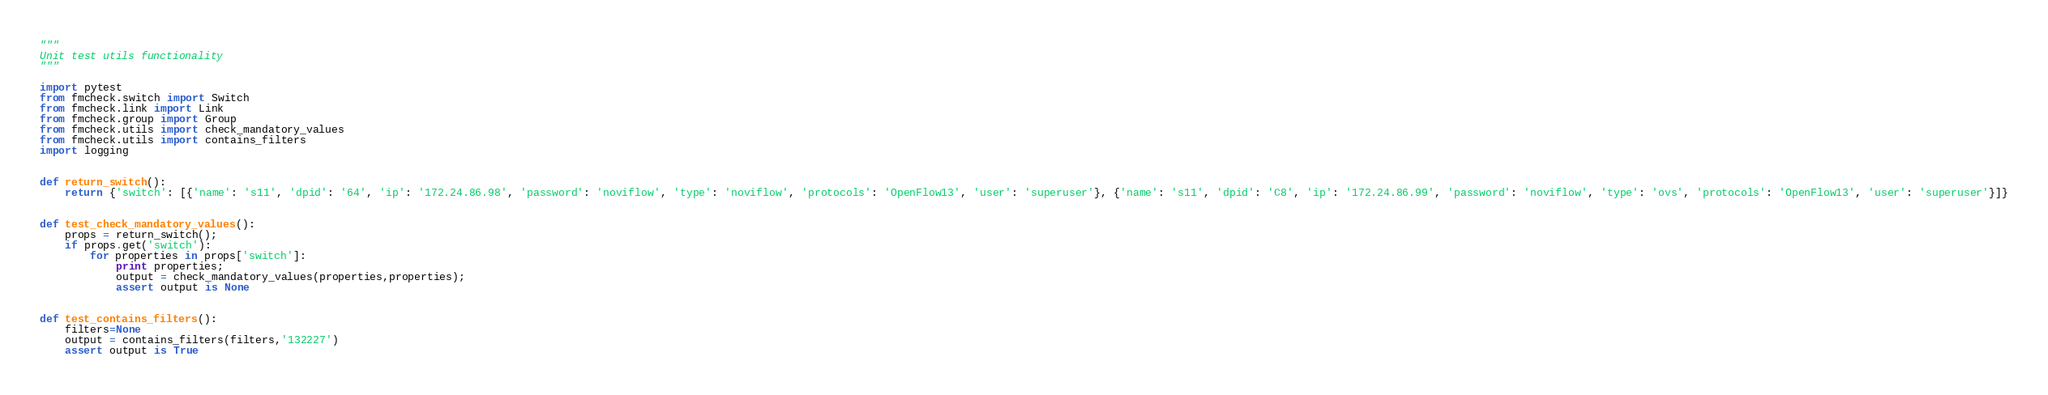<code> <loc_0><loc_0><loc_500><loc_500><_Python_>"""
Unit test utils functionality 
"""

import pytest
from fmcheck.switch import Switch
from fmcheck.link import Link
from fmcheck.group import Group
from fmcheck.utils import check_mandatory_values
from fmcheck.utils import contains_filters
import logging


def return_switch():
    return {'switch': [{'name': 's11', 'dpid': '64', 'ip': '172.24.86.98', 'password': 'noviflow', 'type': 'noviflow', 'protocols': 'OpenFlow13', 'user': 'superuser'}, {'name': 's11', 'dpid': 'C8', 'ip': '172.24.86.99', 'password': 'noviflow', 'type': 'ovs', 'protocols': 'OpenFlow13', 'user': 'superuser'}]}


def test_check_mandatory_values():
    props = return_switch();
    if props.get('switch'):
        for properties in props['switch']:
            print properties;
            output = check_mandatory_values(properties,properties);
            assert output is None


def test_contains_filters():
    filters=None
    output = contains_filters(filters,'132227')
    assert output is True
</code> 